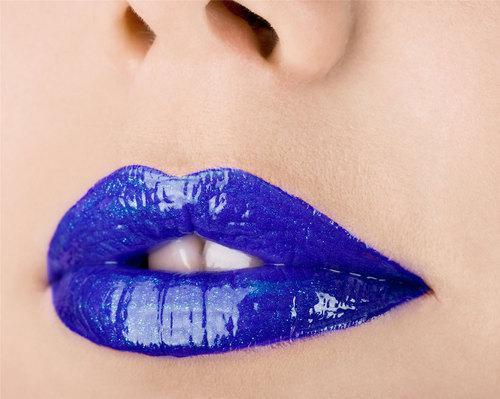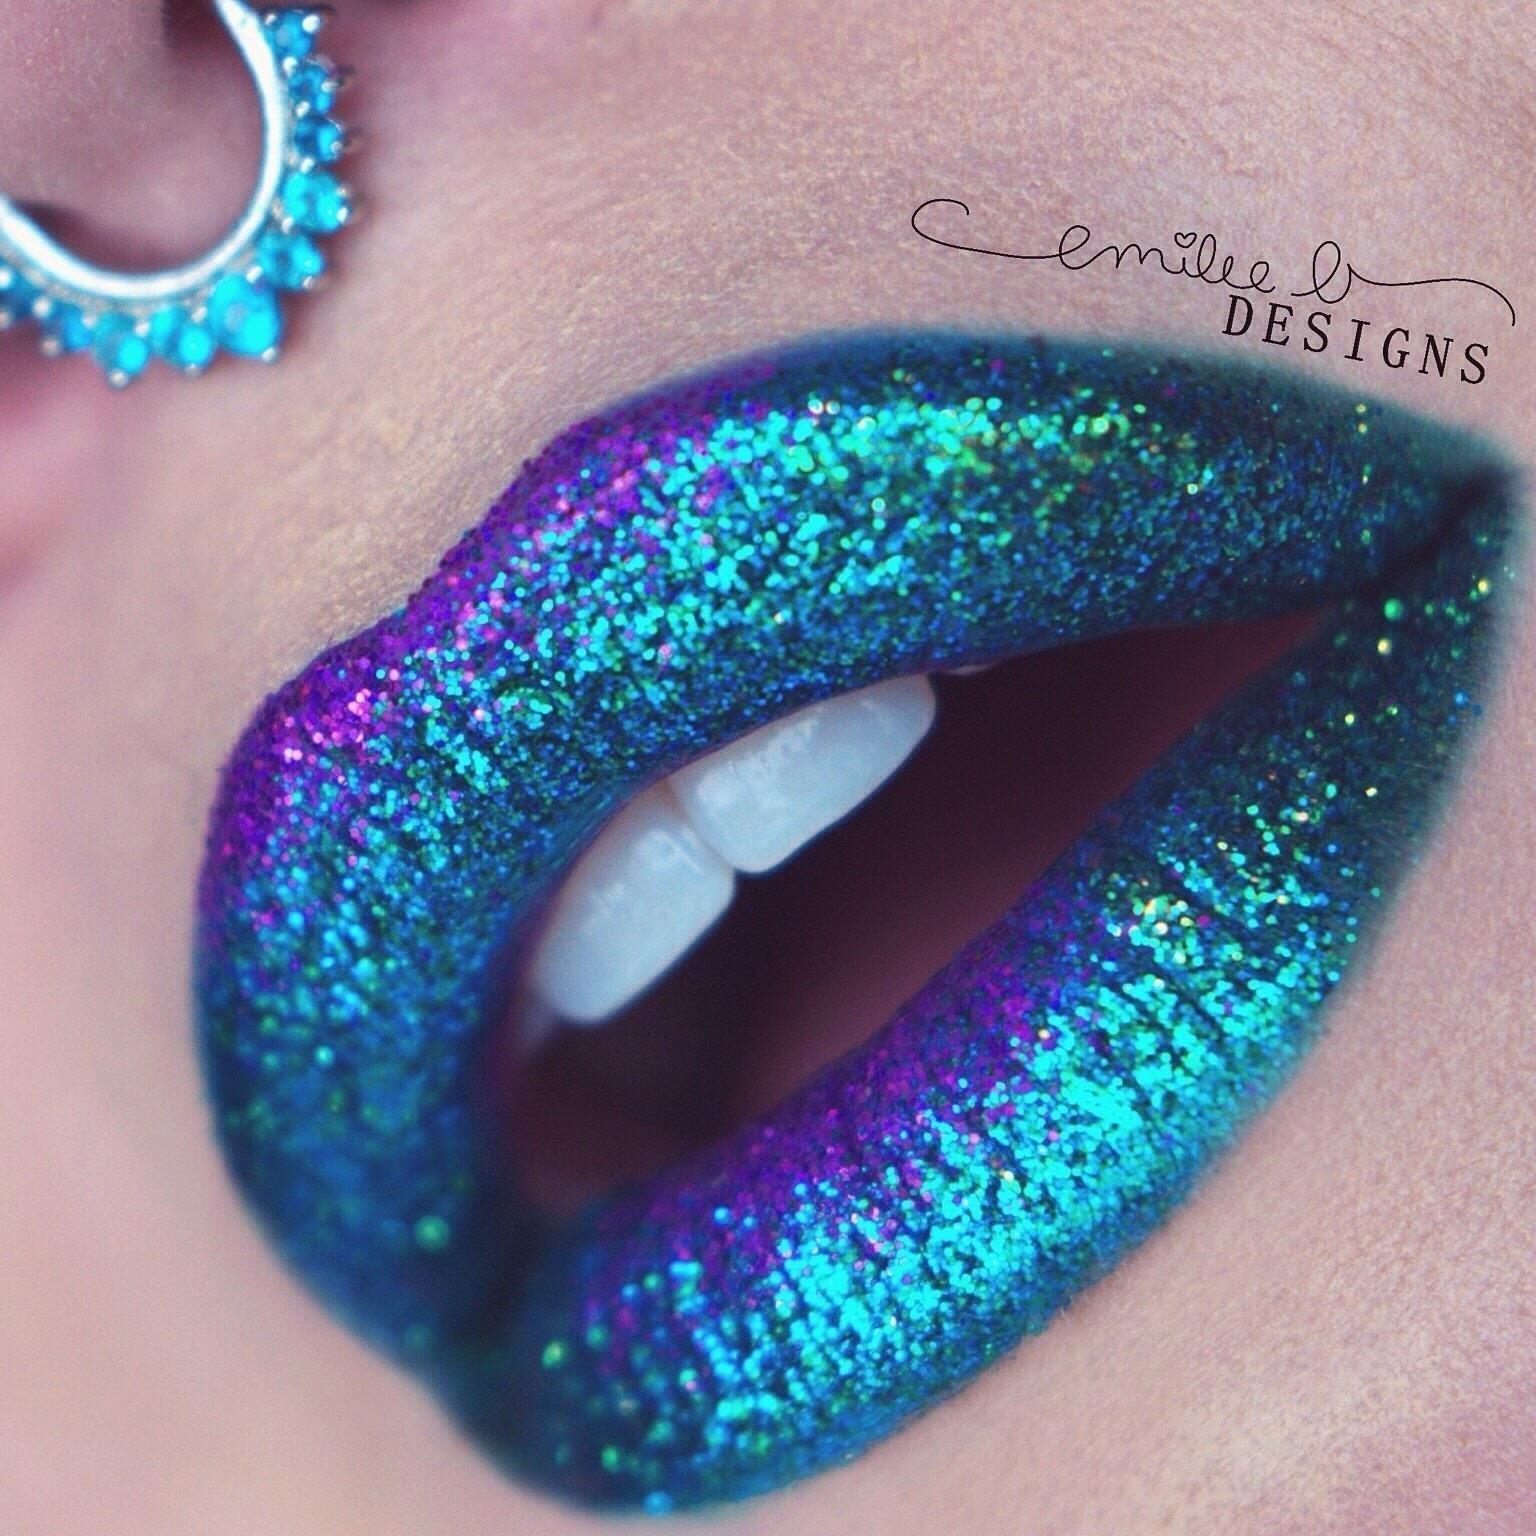The first image is the image on the left, the second image is the image on the right. Given the left and right images, does the statement "A single rhinestone stud is directly above a pair of glittery lips in one image." hold true? Answer yes or no. No. The first image is the image on the left, the second image is the image on the right. Evaluate the accuracy of this statement regarding the images: "One of the lips has a piercing directly above the upper lip that is not attached to the nose.". Is it true? Answer yes or no. No. 